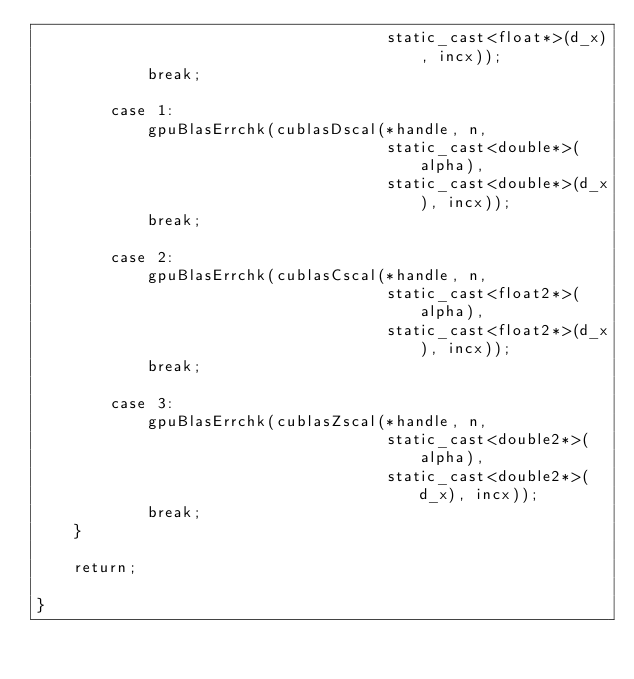<code> <loc_0><loc_0><loc_500><loc_500><_Cuda_>                                      static_cast<float*>(d_x), incx));
            break;

        case 1:
            gpuBlasErrchk(cublasDscal(*handle, n,
                                      static_cast<double*>(alpha),
                                      static_cast<double*>(d_x), incx));
            break;

        case 2:
            gpuBlasErrchk(cublasCscal(*handle, n,
                                      static_cast<float2*>(alpha),
                                      static_cast<float2*>(d_x), incx));
            break;

        case 3:
            gpuBlasErrchk(cublasZscal(*handle, n,
                                      static_cast<double2*>(alpha),
                                      static_cast<double2*>(d_x), incx));
            break;
    }

    return;

}
</code> 